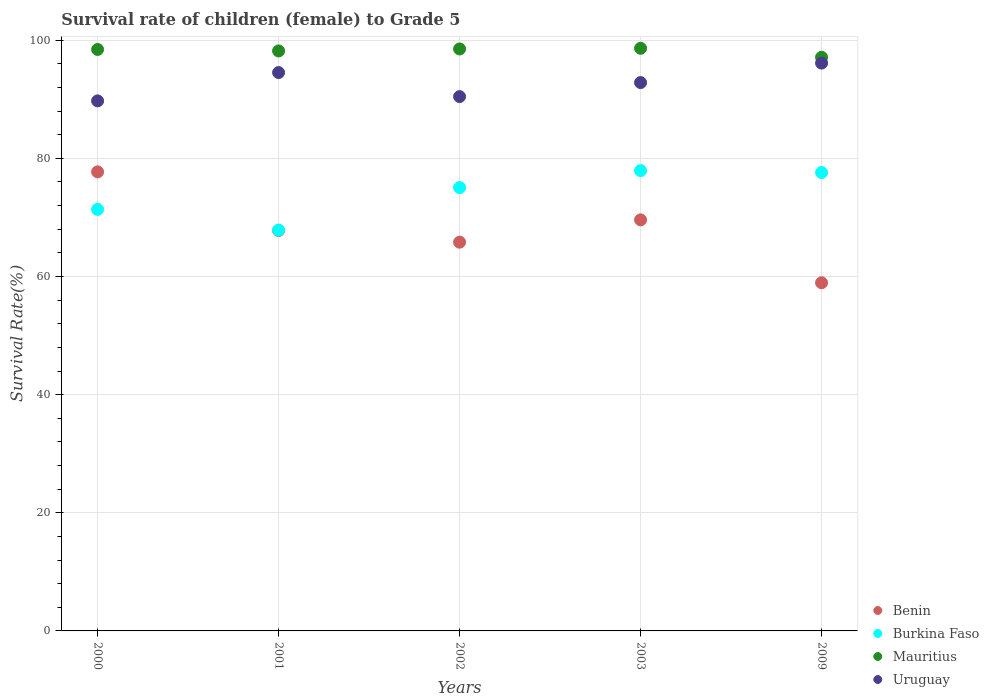How many different coloured dotlines are there?
Keep it short and to the point. 4. What is the survival rate of female children to grade 5 in Mauritius in 2000?
Your answer should be compact. 98.44. Across all years, what is the maximum survival rate of female children to grade 5 in Burkina Faso?
Your answer should be compact. 77.92. Across all years, what is the minimum survival rate of female children to grade 5 in Benin?
Provide a succinct answer. 58.94. In which year was the survival rate of female children to grade 5 in Burkina Faso maximum?
Offer a very short reply. 2003. In which year was the survival rate of female children to grade 5 in Benin minimum?
Provide a short and direct response. 2009. What is the total survival rate of female children to grade 5 in Uruguay in the graph?
Keep it short and to the point. 463.67. What is the difference between the survival rate of female children to grade 5 in Burkina Faso in 2001 and that in 2009?
Give a very brief answer. -9.74. What is the difference between the survival rate of female children to grade 5 in Mauritius in 2002 and the survival rate of female children to grade 5 in Benin in 2001?
Ensure brevity in your answer.  30.74. What is the average survival rate of female children to grade 5 in Burkina Faso per year?
Provide a succinct answer. 73.96. In the year 2002, what is the difference between the survival rate of female children to grade 5 in Mauritius and survival rate of female children to grade 5 in Uruguay?
Your answer should be very brief. 8.07. What is the ratio of the survival rate of female children to grade 5 in Uruguay in 2000 to that in 2002?
Keep it short and to the point. 0.99. Is the survival rate of female children to grade 5 in Uruguay in 2003 less than that in 2009?
Your response must be concise. Yes. What is the difference between the highest and the second highest survival rate of female children to grade 5 in Burkina Faso?
Offer a very short reply. 0.32. What is the difference between the highest and the lowest survival rate of female children to grade 5 in Uruguay?
Your answer should be very brief. 6.4. In how many years, is the survival rate of female children to grade 5 in Mauritius greater than the average survival rate of female children to grade 5 in Mauritius taken over all years?
Provide a short and direct response. 4. Is the sum of the survival rate of female children to grade 5 in Benin in 2000 and 2003 greater than the maximum survival rate of female children to grade 5 in Uruguay across all years?
Ensure brevity in your answer.  Yes. Is it the case that in every year, the sum of the survival rate of female children to grade 5 in Mauritius and survival rate of female children to grade 5 in Benin  is greater than the sum of survival rate of female children to grade 5 in Burkina Faso and survival rate of female children to grade 5 in Uruguay?
Your response must be concise. No. Is it the case that in every year, the sum of the survival rate of female children to grade 5 in Uruguay and survival rate of female children to grade 5 in Burkina Faso  is greater than the survival rate of female children to grade 5 in Benin?
Offer a terse response. Yes. Does the survival rate of female children to grade 5 in Uruguay monotonically increase over the years?
Provide a short and direct response. No. How many dotlines are there?
Offer a terse response. 4. How many years are there in the graph?
Offer a very short reply. 5. What is the difference between two consecutive major ticks on the Y-axis?
Offer a very short reply. 20. Are the values on the major ticks of Y-axis written in scientific E-notation?
Provide a succinct answer. No. Does the graph contain any zero values?
Offer a very short reply. No. Does the graph contain grids?
Make the answer very short. Yes. How are the legend labels stacked?
Your answer should be very brief. Vertical. What is the title of the graph?
Your answer should be very brief. Survival rate of children (female) to Grade 5. Does "Bahrain" appear as one of the legend labels in the graph?
Give a very brief answer. No. What is the label or title of the Y-axis?
Your answer should be compact. Survival Rate(%). What is the Survival Rate(%) of Benin in 2000?
Ensure brevity in your answer.  77.72. What is the Survival Rate(%) of Burkina Faso in 2000?
Make the answer very short. 71.36. What is the Survival Rate(%) of Mauritius in 2000?
Provide a succinct answer. 98.44. What is the Survival Rate(%) in Uruguay in 2000?
Ensure brevity in your answer.  89.73. What is the Survival Rate(%) of Benin in 2001?
Your response must be concise. 67.78. What is the Survival Rate(%) of Burkina Faso in 2001?
Offer a terse response. 67.86. What is the Survival Rate(%) of Mauritius in 2001?
Your response must be concise. 98.19. What is the Survival Rate(%) of Uruguay in 2001?
Your answer should be very brief. 94.53. What is the Survival Rate(%) in Benin in 2002?
Make the answer very short. 65.81. What is the Survival Rate(%) of Burkina Faso in 2002?
Make the answer very short. 75.05. What is the Survival Rate(%) of Mauritius in 2002?
Ensure brevity in your answer.  98.52. What is the Survival Rate(%) of Uruguay in 2002?
Provide a succinct answer. 90.46. What is the Survival Rate(%) of Benin in 2003?
Give a very brief answer. 69.59. What is the Survival Rate(%) of Burkina Faso in 2003?
Give a very brief answer. 77.92. What is the Survival Rate(%) of Mauritius in 2003?
Provide a short and direct response. 98.63. What is the Survival Rate(%) of Uruguay in 2003?
Your response must be concise. 92.83. What is the Survival Rate(%) of Benin in 2009?
Your answer should be very brief. 58.94. What is the Survival Rate(%) of Burkina Faso in 2009?
Your answer should be very brief. 77.6. What is the Survival Rate(%) of Mauritius in 2009?
Provide a short and direct response. 97.11. What is the Survival Rate(%) of Uruguay in 2009?
Provide a short and direct response. 96.13. Across all years, what is the maximum Survival Rate(%) in Benin?
Provide a succinct answer. 77.72. Across all years, what is the maximum Survival Rate(%) of Burkina Faso?
Offer a very short reply. 77.92. Across all years, what is the maximum Survival Rate(%) of Mauritius?
Ensure brevity in your answer.  98.63. Across all years, what is the maximum Survival Rate(%) of Uruguay?
Keep it short and to the point. 96.13. Across all years, what is the minimum Survival Rate(%) of Benin?
Ensure brevity in your answer.  58.94. Across all years, what is the minimum Survival Rate(%) of Burkina Faso?
Ensure brevity in your answer.  67.86. Across all years, what is the minimum Survival Rate(%) in Mauritius?
Keep it short and to the point. 97.11. Across all years, what is the minimum Survival Rate(%) in Uruguay?
Offer a terse response. 89.73. What is the total Survival Rate(%) of Benin in the graph?
Offer a terse response. 339.83. What is the total Survival Rate(%) in Burkina Faso in the graph?
Make the answer very short. 369.8. What is the total Survival Rate(%) of Mauritius in the graph?
Provide a short and direct response. 490.89. What is the total Survival Rate(%) in Uruguay in the graph?
Ensure brevity in your answer.  463.67. What is the difference between the Survival Rate(%) in Benin in 2000 and that in 2001?
Offer a terse response. 9.94. What is the difference between the Survival Rate(%) of Burkina Faso in 2000 and that in 2001?
Your answer should be compact. 3.51. What is the difference between the Survival Rate(%) in Mauritius in 2000 and that in 2001?
Ensure brevity in your answer.  0.25. What is the difference between the Survival Rate(%) in Uruguay in 2000 and that in 2001?
Ensure brevity in your answer.  -4.79. What is the difference between the Survival Rate(%) of Benin in 2000 and that in 2002?
Provide a short and direct response. 11.91. What is the difference between the Survival Rate(%) of Burkina Faso in 2000 and that in 2002?
Make the answer very short. -3.69. What is the difference between the Survival Rate(%) in Mauritius in 2000 and that in 2002?
Your answer should be very brief. -0.09. What is the difference between the Survival Rate(%) in Uruguay in 2000 and that in 2002?
Keep it short and to the point. -0.72. What is the difference between the Survival Rate(%) in Benin in 2000 and that in 2003?
Make the answer very short. 8.13. What is the difference between the Survival Rate(%) of Burkina Faso in 2000 and that in 2003?
Provide a short and direct response. -6.56. What is the difference between the Survival Rate(%) in Mauritius in 2000 and that in 2003?
Make the answer very short. -0.2. What is the difference between the Survival Rate(%) in Uruguay in 2000 and that in 2003?
Make the answer very short. -3.1. What is the difference between the Survival Rate(%) of Benin in 2000 and that in 2009?
Make the answer very short. 18.78. What is the difference between the Survival Rate(%) in Burkina Faso in 2000 and that in 2009?
Keep it short and to the point. -6.24. What is the difference between the Survival Rate(%) of Mauritius in 2000 and that in 2009?
Ensure brevity in your answer.  1.32. What is the difference between the Survival Rate(%) of Uruguay in 2000 and that in 2009?
Your response must be concise. -6.4. What is the difference between the Survival Rate(%) of Benin in 2001 and that in 2002?
Keep it short and to the point. 1.97. What is the difference between the Survival Rate(%) of Burkina Faso in 2001 and that in 2002?
Give a very brief answer. -7.2. What is the difference between the Survival Rate(%) of Mauritius in 2001 and that in 2002?
Your answer should be compact. -0.34. What is the difference between the Survival Rate(%) in Uruguay in 2001 and that in 2002?
Provide a succinct answer. 4.07. What is the difference between the Survival Rate(%) of Benin in 2001 and that in 2003?
Provide a succinct answer. -1.81. What is the difference between the Survival Rate(%) of Burkina Faso in 2001 and that in 2003?
Offer a very short reply. -10.07. What is the difference between the Survival Rate(%) in Mauritius in 2001 and that in 2003?
Provide a succinct answer. -0.45. What is the difference between the Survival Rate(%) in Uruguay in 2001 and that in 2003?
Provide a short and direct response. 1.7. What is the difference between the Survival Rate(%) of Benin in 2001 and that in 2009?
Keep it short and to the point. 8.84. What is the difference between the Survival Rate(%) in Burkina Faso in 2001 and that in 2009?
Make the answer very short. -9.74. What is the difference between the Survival Rate(%) of Mauritius in 2001 and that in 2009?
Ensure brevity in your answer.  1.07. What is the difference between the Survival Rate(%) in Uruguay in 2001 and that in 2009?
Your answer should be very brief. -1.6. What is the difference between the Survival Rate(%) in Benin in 2002 and that in 2003?
Your response must be concise. -3.78. What is the difference between the Survival Rate(%) in Burkina Faso in 2002 and that in 2003?
Provide a succinct answer. -2.87. What is the difference between the Survival Rate(%) of Mauritius in 2002 and that in 2003?
Your response must be concise. -0.11. What is the difference between the Survival Rate(%) in Uruguay in 2002 and that in 2003?
Ensure brevity in your answer.  -2.37. What is the difference between the Survival Rate(%) in Benin in 2002 and that in 2009?
Your response must be concise. 6.87. What is the difference between the Survival Rate(%) in Burkina Faso in 2002 and that in 2009?
Provide a short and direct response. -2.55. What is the difference between the Survival Rate(%) in Mauritius in 2002 and that in 2009?
Your response must be concise. 1.41. What is the difference between the Survival Rate(%) in Uruguay in 2002 and that in 2009?
Provide a short and direct response. -5.67. What is the difference between the Survival Rate(%) in Benin in 2003 and that in 2009?
Keep it short and to the point. 10.65. What is the difference between the Survival Rate(%) in Burkina Faso in 2003 and that in 2009?
Offer a very short reply. 0.32. What is the difference between the Survival Rate(%) of Mauritius in 2003 and that in 2009?
Ensure brevity in your answer.  1.52. What is the difference between the Survival Rate(%) of Uruguay in 2003 and that in 2009?
Your answer should be compact. -3.3. What is the difference between the Survival Rate(%) of Benin in 2000 and the Survival Rate(%) of Burkina Faso in 2001?
Make the answer very short. 9.86. What is the difference between the Survival Rate(%) in Benin in 2000 and the Survival Rate(%) in Mauritius in 2001?
Make the answer very short. -20.47. What is the difference between the Survival Rate(%) in Benin in 2000 and the Survival Rate(%) in Uruguay in 2001?
Provide a short and direct response. -16.81. What is the difference between the Survival Rate(%) of Burkina Faso in 2000 and the Survival Rate(%) of Mauritius in 2001?
Give a very brief answer. -26.82. What is the difference between the Survival Rate(%) of Burkina Faso in 2000 and the Survival Rate(%) of Uruguay in 2001?
Provide a short and direct response. -23.16. What is the difference between the Survival Rate(%) in Mauritius in 2000 and the Survival Rate(%) in Uruguay in 2001?
Ensure brevity in your answer.  3.91. What is the difference between the Survival Rate(%) in Benin in 2000 and the Survival Rate(%) in Burkina Faso in 2002?
Keep it short and to the point. 2.66. What is the difference between the Survival Rate(%) in Benin in 2000 and the Survival Rate(%) in Mauritius in 2002?
Offer a terse response. -20.81. What is the difference between the Survival Rate(%) in Benin in 2000 and the Survival Rate(%) in Uruguay in 2002?
Provide a short and direct response. -12.74. What is the difference between the Survival Rate(%) of Burkina Faso in 2000 and the Survival Rate(%) of Mauritius in 2002?
Provide a succinct answer. -27.16. What is the difference between the Survival Rate(%) of Burkina Faso in 2000 and the Survival Rate(%) of Uruguay in 2002?
Offer a very short reply. -19.09. What is the difference between the Survival Rate(%) of Mauritius in 2000 and the Survival Rate(%) of Uruguay in 2002?
Provide a succinct answer. 7.98. What is the difference between the Survival Rate(%) in Benin in 2000 and the Survival Rate(%) in Burkina Faso in 2003?
Provide a short and direct response. -0.21. What is the difference between the Survival Rate(%) in Benin in 2000 and the Survival Rate(%) in Mauritius in 2003?
Provide a short and direct response. -20.92. What is the difference between the Survival Rate(%) of Benin in 2000 and the Survival Rate(%) of Uruguay in 2003?
Give a very brief answer. -15.11. What is the difference between the Survival Rate(%) of Burkina Faso in 2000 and the Survival Rate(%) of Mauritius in 2003?
Your response must be concise. -27.27. What is the difference between the Survival Rate(%) in Burkina Faso in 2000 and the Survival Rate(%) in Uruguay in 2003?
Your answer should be compact. -21.47. What is the difference between the Survival Rate(%) of Mauritius in 2000 and the Survival Rate(%) of Uruguay in 2003?
Offer a very short reply. 5.61. What is the difference between the Survival Rate(%) of Benin in 2000 and the Survival Rate(%) of Burkina Faso in 2009?
Keep it short and to the point. 0.12. What is the difference between the Survival Rate(%) in Benin in 2000 and the Survival Rate(%) in Mauritius in 2009?
Keep it short and to the point. -19.4. What is the difference between the Survival Rate(%) in Benin in 2000 and the Survival Rate(%) in Uruguay in 2009?
Provide a succinct answer. -18.41. What is the difference between the Survival Rate(%) of Burkina Faso in 2000 and the Survival Rate(%) of Mauritius in 2009?
Give a very brief answer. -25.75. What is the difference between the Survival Rate(%) in Burkina Faso in 2000 and the Survival Rate(%) in Uruguay in 2009?
Provide a succinct answer. -24.77. What is the difference between the Survival Rate(%) of Mauritius in 2000 and the Survival Rate(%) of Uruguay in 2009?
Provide a short and direct response. 2.31. What is the difference between the Survival Rate(%) of Benin in 2001 and the Survival Rate(%) of Burkina Faso in 2002?
Give a very brief answer. -7.27. What is the difference between the Survival Rate(%) in Benin in 2001 and the Survival Rate(%) in Mauritius in 2002?
Offer a very short reply. -30.74. What is the difference between the Survival Rate(%) of Benin in 2001 and the Survival Rate(%) of Uruguay in 2002?
Offer a terse response. -22.68. What is the difference between the Survival Rate(%) of Burkina Faso in 2001 and the Survival Rate(%) of Mauritius in 2002?
Provide a succinct answer. -30.67. What is the difference between the Survival Rate(%) in Burkina Faso in 2001 and the Survival Rate(%) in Uruguay in 2002?
Give a very brief answer. -22.6. What is the difference between the Survival Rate(%) in Mauritius in 2001 and the Survival Rate(%) in Uruguay in 2002?
Ensure brevity in your answer.  7.73. What is the difference between the Survival Rate(%) in Benin in 2001 and the Survival Rate(%) in Burkina Faso in 2003?
Make the answer very short. -10.14. What is the difference between the Survival Rate(%) of Benin in 2001 and the Survival Rate(%) of Mauritius in 2003?
Your answer should be very brief. -30.85. What is the difference between the Survival Rate(%) in Benin in 2001 and the Survival Rate(%) in Uruguay in 2003?
Your answer should be very brief. -25.05. What is the difference between the Survival Rate(%) of Burkina Faso in 2001 and the Survival Rate(%) of Mauritius in 2003?
Give a very brief answer. -30.78. What is the difference between the Survival Rate(%) in Burkina Faso in 2001 and the Survival Rate(%) in Uruguay in 2003?
Provide a succinct answer. -24.97. What is the difference between the Survival Rate(%) in Mauritius in 2001 and the Survival Rate(%) in Uruguay in 2003?
Make the answer very short. 5.36. What is the difference between the Survival Rate(%) of Benin in 2001 and the Survival Rate(%) of Burkina Faso in 2009?
Make the answer very short. -9.82. What is the difference between the Survival Rate(%) of Benin in 2001 and the Survival Rate(%) of Mauritius in 2009?
Keep it short and to the point. -29.33. What is the difference between the Survival Rate(%) in Benin in 2001 and the Survival Rate(%) in Uruguay in 2009?
Ensure brevity in your answer.  -28.35. What is the difference between the Survival Rate(%) in Burkina Faso in 2001 and the Survival Rate(%) in Mauritius in 2009?
Offer a very short reply. -29.26. What is the difference between the Survival Rate(%) of Burkina Faso in 2001 and the Survival Rate(%) of Uruguay in 2009?
Your answer should be compact. -28.27. What is the difference between the Survival Rate(%) in Mauritius in 2001 and the Survival Rate(%) in Uruguay in 2009?
Offer a very short reply. 2.06. What is the difference between the Survival Rate(%) in Benin in 2002 and the Survival Rate(%) in Burkina Faso in 2003?
Provide a short and direct response. -12.11. What is the difference between the Survival Rate(%) in Benin in 2002 and the Survival Rate(%) in Mauritius in 2003?
Ensure brevity in your answer.  -32.82. What is the difference between the Survival Rate(%) of Benin in 2002 and the Survival Rate(%) of Uruguay in 2003?
Offer a terse response. -27.02. What is the difference between the Survival Rate(%) of Burkina Faso in 2002 and the Survival Rate(%) of Mauritius in 2003?
Ensure brevity in your answer.  -23.58. What is the difference between the Survival Rate(%) of Burkina Faso in 2002 and the Survival Rate(%) of Uruguay in 2003?
Keep it short and to the point. -17.77. What is the difference between the Survival Rate(%) of Mauritius in 2002 and the Survival Rate(%) of Uruguay in 2003?
Offer a very short reply. 5.69. What is the difference between the Survival Rate(%) in Benin in 2002 and the Survival Rate(%) in Burkina Faso in 2009?
Keep it short and to the point. -11.79. What is the difference between the Survival Rate(%) in Benin in 2002 and the Survival Rate(%) in Mauritius in 2009?
Make the answer very short. -31.3. What is the difference between the Survival Rate(%) in Benin in 2002 and the Survival Rate(%) in Uruguay in 2009?
Your response must be concise. -30.32. What is the difference between the Survival Rate(%) in Burkina Faso in 2002 and the Survival Rate(%) in Mauritius in 2009?
Offer a very short reply. -22.06. What is the difference between the Survival Rate(%) in Burkina Faso in 2002 and the Survival Rate(%) in Uruguay in 2009?
Keep it short and to the point. -21.07. What is the difference between the Survival Rate(%) in Mauritius in 2002 and the Survival Rate(%) in Uruguay in 2009?
Provide a short and direct response. 2.39. What is the difference between the Survival Rate(%) in Benin in 2003 and the Survival Rate(%) in Burkina Faso in 2009?
Offer a terse response. -8.01. What is the difference between the Survival Rate(%) of Benin in 2003 and the Survival Rate(%) of Mauritius in 2009?
Your answer should be compact. -27.52. What is the difference between the Survival Rate(%) in Benin in 2003 and the Survival Rate(%) in Uruguay in 2009?
Offer a very short reply. -26.54. What is the difference between the Survival Rate(%) in Burkina Faso in 2003 and the Survival Rate(%) in Mauritius in 2009?
Give a very brief answer. -19.19. What is the difference between the Survival Rate(%) in Burkina Faso in 2003 and the Survival Rate(%) in Uruguay in 2009?
Your answer should be very brief. -18.2. What is the difference between the Survival Rate(%) in Mauritius in 2003 and the Survival Rate(%) in Uruguay in 2009?
Provide a succinct answer. 2.5. What is the average Survival Rate(%) of Benin per year?
Give a very brief answer. 67.97. What is the average Survival Rate(%) of Burkina Faso per year?
Your answer should be very brief. 73.96. What is the average Survival Rate(%) of Mauritius per year?
Give a very brief answer. 98.18. What is the average Survival Rate(%) of Uruguay per year?
Your response must be concise. 92.73. In the year 2000, what is the difference between the Survival Rate(%) of Benin and Survival Rate(%) of Burkina Faso?
Offer a very short reply. 6.35. In the year 2000, what is the difference between the Survival Rate(%) in Benin and Survival Rate(%) in Mauritius?
Provide a succinct answer. -20.72. In the year 2000, what is the difference between the Survival Rate(%) in Benin and Survival Rate(%) in Uruguay?
Offer a terse response. -12.02. In the year 2000, what is the difference between the Survival Rate(%) in Burkina Faso and Survival Rate(%) in Mauritius?
Offer a terse response. -27.07. In the year 2000, what is the difference between the Survival Rate(%) in Burkina Faso and Survival Rate(%) in Uruguay?
Keep it short and to the point. -18.37. In the year 2000, what is the difference between the Survival Rate(%) of Mauritius and Survival Rate(%) of Uruguay?
Your answer should be compact. 8.7. In the year 2001, what is the difference between the Survival Rate(%) in Benin and Survival Rate(%) in Burkina Faso?
Your answer should be compact. -0.07. In the year 2001, what is the difference between the Survival Rate(%) of Benin and Survival Rate(%) of Mauritius?
Keep it short and to the point. -30.4. In the year 2001, what is the difference between the Survival Rate(%) of Benin and Survival Rate(%) of Uruguay?
Your answer should be very brief. -26.75. In the year 2001, what is the difference between the Survival Rate(%) in Burkina Faso and Survival Rate(%) in Mauritius?
Offer a terse response. -30.33. In the year 2001, what is the difference between the Survival Rate(%) of Burkina Faso and Survival Rate(%) of Uruguay?
Keep it short and to the point. -26.67. In the year 2001, what is the difference between the Survival Rate(%) of Mauritius and Survival Rate(%) of Uruguay?
Ensure brevity in your answer.  3.66. In the year 2002, what is the difference between the Survival Rate(%) in Benin and Survival Rate(%) in Burkina Faso?
Offer a very short reply. -9.24. In the year 2002, what is the difference between the Survival Rate(%) in Benin and Survival Rate(%) in Mauritius?
Your answer should be very brief. -32.71. In the year 2002, what is the difference between the Survival Rate(%) of Benin and Survival Rate(%) of Uruguay?
Your answer should be compact. -24.65. In the year 2002, what is the difference between the Survival Rate(%) in Burkina Faso and Survival Rate(%) in Mauritius?
Provide a succinct answer. -23.47. In the year 2002, what is the difference between the Survival Rate(%) of Burkina Faso and Survival Rate(%) of Uruguay?
Your response must be concise. -15.4. In the year 2002, what is the difference between the Survival Rate(%) in Mauritius and Survival Rate(%) in Uruguay?
Ensure brevity in your answer.  8.07. In the year 2003, what is the difference between the Survival Rate(%) in Benin and Survival Rate(%) in Burkina Faso?
Give a very brief answer. -8.34. In the year 2003, what is the difference between the Survival Rate(%) of Benin and Survival Rate(%) of Mauritius?
Ensure brevity in your answer.  -29.04. In the year 2003, what is the difference between the Survival Rate(%) in Benin and Survival Rate(%) in Uruguay?
Offer a very short reply. -23.24. In the year 2003, what is the difference between the Survival Rate(%) in Burkina Faso and Survival Rate(%) in Mauritius?
Give a very brief answer. -20.71. In the year 2003, what is the difference between the Survival Rate(%) in Burkina Faso and Survival Rate(%) in Uruguay?
Your answer should be very brief. -14.9. In the year 2003, what is the difference between the Survival Rate(%) in Mauritius and Survival Rate(%) in Uruguay?
Offer a terse response. 5.8. In the year 2009, what is the difference between the Survival Rate(%) in Benin and Survival Rate(%) in Burkina Faso?
Keep it short and to the point. -18.66. In the year 2009, what is the difference between the Survival Rate(%) in Benin and Survival Rate(%) in Mauritius?
Ensure brevity in your answer.  -38.17. In the year 2009, what is the difference between the Survival Rate(%) of Benin and Survival Rate(%) of Uruguay?
Keep it short and to the point. -37.19. In the year 2009, what is the difference between the Survival Rate(%) of Burkina Faso and Survival Rate(%) of Mauritius?
Provide a short and direct response. -19.51. In the year 2009, what is the difference between the Survival Rate(%) in Burkina Faso and Survival Rate(%) in Uruguay?
Give a very brief answer. -18.53. In the year 2009, what is the difference between the Survival Rate(%) of Mauritius and Survival Rate(%) of Uruguay?
Offer a very short reply. 0.98. What is the ratio of the Survival Rate(%) of Benin in 2000 to that in 2001?
Your answer should be compact. 1.15. What is the ratio of the Survival Rate(%) in Burkina Faso in 2000 to that in 2001?
Provide a succinct answer. 1.05. What is the ratio of the Survival Rate(%) of Mauritius in 2000 to that in 2001?
Offer a very short reply. 1. What is the ratio of the Survival Rate(%) of Uruguay in 2000 to that in 2001?
Offer a very short reply. 0.95. What is the ratio of the Survival Rate(%) of Benin in 2000 to that in 2002?
Your response must be concise. 1.18. What is the ratio of the Survival Rate(%) of Burkina Faso in 2000 to that in 2002?
Your answer should be compact. 0.95. What is the ratio of the Survival Rate(%) of Benin in 2000 to that in 2003?
Your answer should be compact. 1.12. What is the ratio of the Survival Rate(%) of Burkina Faso in 2000 to that in 2003?
Offer a very short reply. 0.92. What is the ratio of the Survival Rate(%) of Mauritius in 2000 to that in 2003?
Offer a terse response. 1. What is the ratio of the Survival Rate(%) of Uruguay in 2000 to that in 2003?
Ensure brevity in your answer.  0.97. What is the ratio of the Survival Rate(%) of Benin in 2000 to that in 2009?
Offer a terse response. 1.32. What is the ratio of the Survival Rate(%) of Burkina Faso in 2000 to that in 2009?
Offer a very short reply. 0.92. What is the ratio of the Survival Rate(%) of Mauritius in 2000 to that in 2009?
Keep it short and to the point. 1.01. What is the ratio of the Survival Rate(%) of Uruguay in 2000 to that in 2009?
Your answer should be very brief. 0.93. What is the ratio of the Survival Rate(%) of Benin in 2001 to that in 2002?
Your answer should be compact. 1.03. What is the ratio of the Survival Rate(%) of Burkina Faso in 2001 to that in 2002?
Provide a short and direct response. 0.9. What is the ratio of the Survival Rate(%) of Uruguay in 2001 to that in 2002?
Give a very brief answer. 1.04. What is the ratio of the Survival Rate(%) of Burkina Faso in 2001 to that in 2003?
Make the answer very short. 0.87. What is the ratio of the Survival Rate(%) of Mauritius in 2001 to that in 2003?
Offer a terse response. 1. What is the ratio of the Survival Rate(%) in Uruguay in 2001 to that in 2003?
Provide a succinct answer. 1.02. What is the ratio of the Survival Rate(%) in Benin in 2001 to that in 2009?
Offer a very short reply. 1.15. What is the ratio of the Survival Rate(%) of Burkina Faso in 2001 to that in 2009?
Keep it short and to the point. 0.87. What is the ratio of the Survival Rate(%) of Mauritius in 2001 to that in 2009?
Your answer should be very brief. 1.01. What is the ratio of the Survival Rate(%) in Uruguay in 2001 to that in 2009?
Keep it short and to the point. 0.98. What is the ratio of the Survival Rate(%) of Benin in 2002 to that in 2003?
Offer a very short reply. 0.95. What is the ratio of the Survival Rate(%) in Burkina Faso in 2002 to that in 2003?
Provide a succinct answer. 0.96. What is the ratio of the Survival Rate(%) in Uruguay in 2002 to that in 2003?
Provide a short and direct response. 0.97. What is the ratio of the Survival Rate(%) in Benin in 2002 to that in 2009?
Your response must be concise. 1.12. What is the ratio of the Survival Rate(%) of Burkina Faso in 2002 to that in 2009?
Your answer should be very brief. 0.97. What is the ratio of the Survival Rate(%) of Mauritius in 2002 to that in 2009?
Ensure brevity in your answer.  1.01. What is the ratio of the Survival Rate(%) in Uruguay in 2002 to that in 2009?
Offer a very short reply. 0.94. What is the ratio of the Survival Rate(%) in Benin in 2003 to that in 2009?
Offer a very short reply. 1.18. What is the ratio of the Survival Rate(%) of Mauritius in 2003 to that in 2009?
Offer a terse response. 1.02. What is the ratio of the Survival Rate(%) in Uruguay in 2003 to that in 2009?
Provide a succinct answer. 0.97. What is the difference between the highest and the second highest Survival Rate(%) of Benin?
Your answer should be very brief. 8.13. What is the difference between the highest and the second highest Survival Rate(%) in Burkina Faso?
Make the answer very short. 0.32. What is the difference between the highest and the second highest Survival Rate(%) of Mauritius?
Keep it short and to the point. 0.11. What is the difference between the highest and the second highest Survival Rate(%) of Uruguay?
Keep it short and to the point. 1.6. What is the difference between the highest and the lowest Survival Rate(%) in Benin?
Provide a short and direct response. 18.78. What is the difference between the highest and the lowest Survival Rate(%) in Burkina Faso?
Your answer should be compact. 10.07. What is the difference between the highest and the lowest Survival Rate(%) in Mauritius?
Make the answer very short. 1.52. What is the difference between the highest and the lowest Survival Rate(%) of Uruguay?
Give a very brief answer. 6.4. 